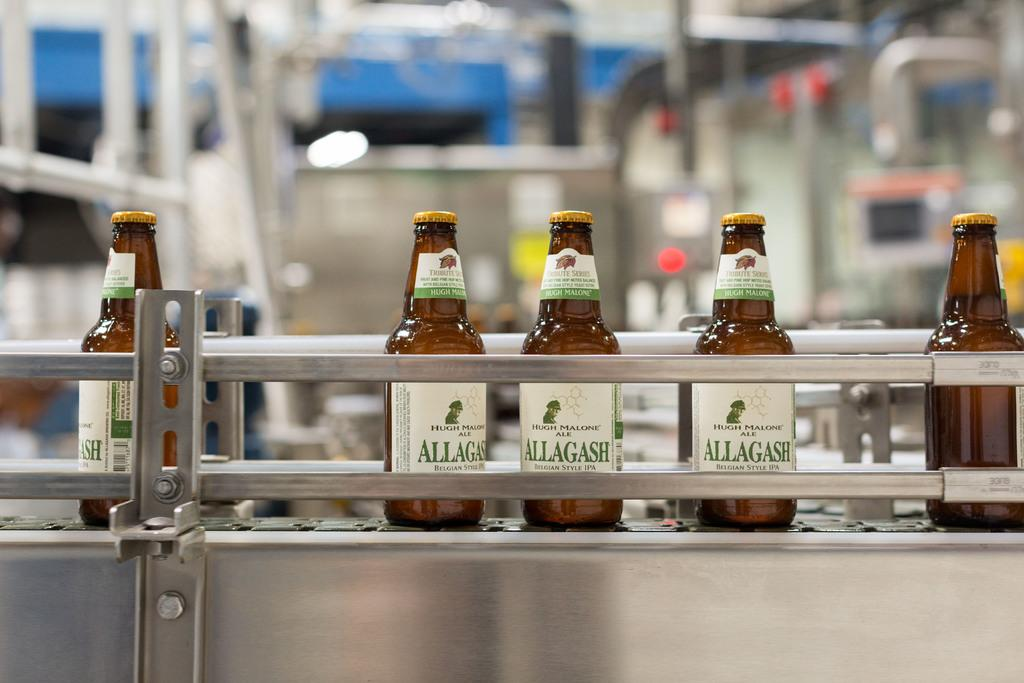What type of beverage containers are present in the image? There are beer bottles in the image. What can be seen in the background of the image? There is machinery visible in the background of the image. What type of jail can be seen in the image? There is no jail present in the image; it features beer bottles and machinery in the background. What is the moon's position in the image? The moon is not visible in the image. 